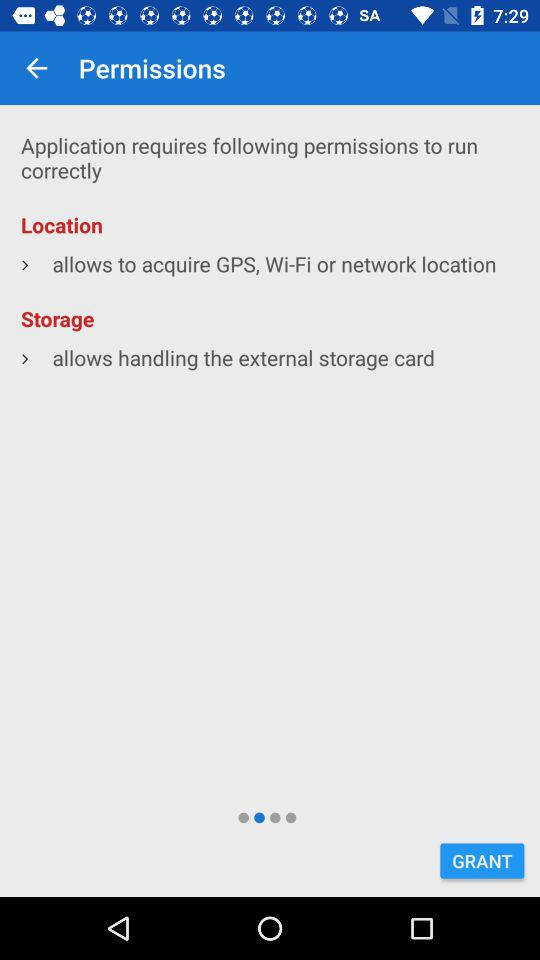What permissions is the application asking for? The application is asking for location and storage permissions. 